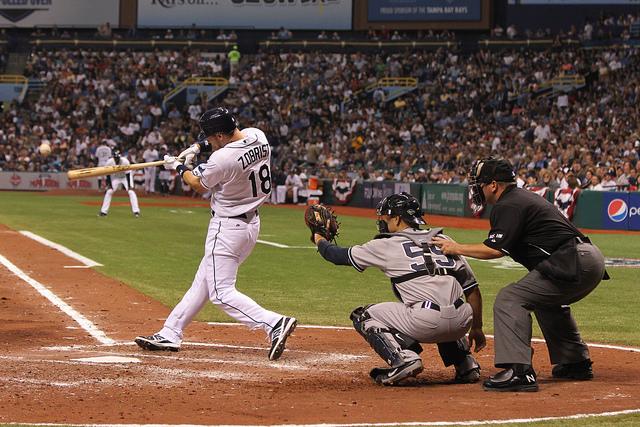What brand of soda is advertised?
Be succinct. Pepsi. Is this pitch a strike?
Concise answer only. No. Has the player already hit the ball?
Write a very short answer. Yes. Who is squatting lower?
Keep it brief. Catcher. Is it nighttime?
Answer briefly. Yes. 